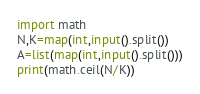Convert code to text. <code><loc_0><loc_0><loc_500><loc_500><_Python_>import math
N,K=map(int,input().split())
A=list(map(int,input().split()))
print(math.ceil(N/K))</code> 